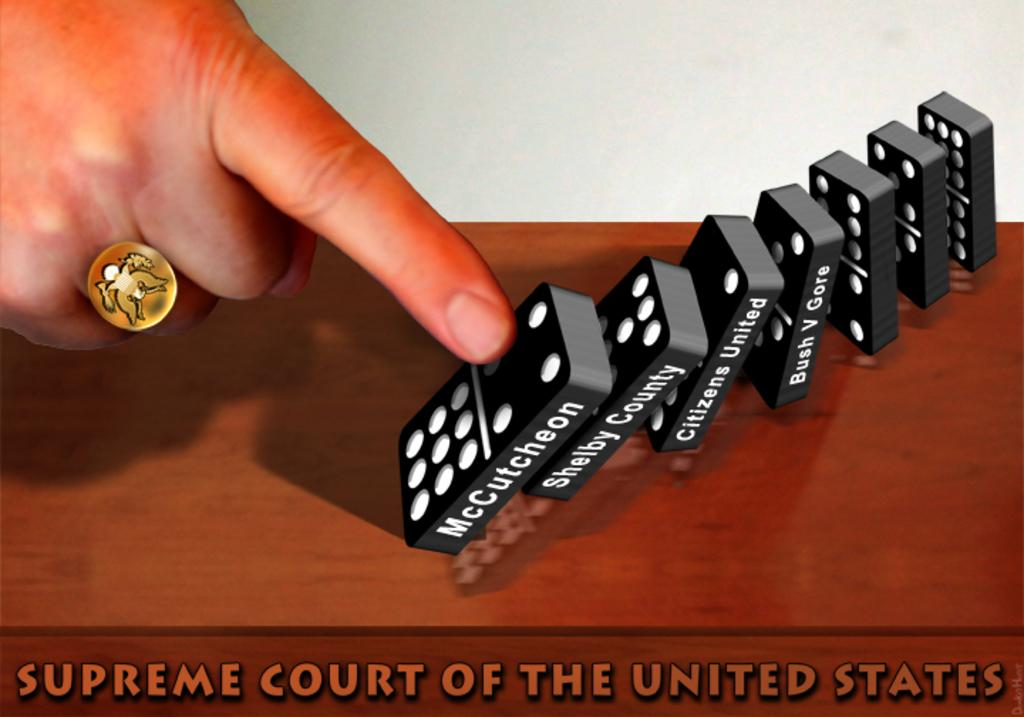<image>
Create a compact narrative representing the image presented. A photo of dominoes that says Supreme Court of the United States at the bottom. 